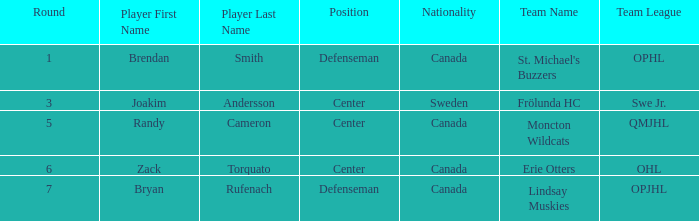What position does Zack Torquato play? Center. 